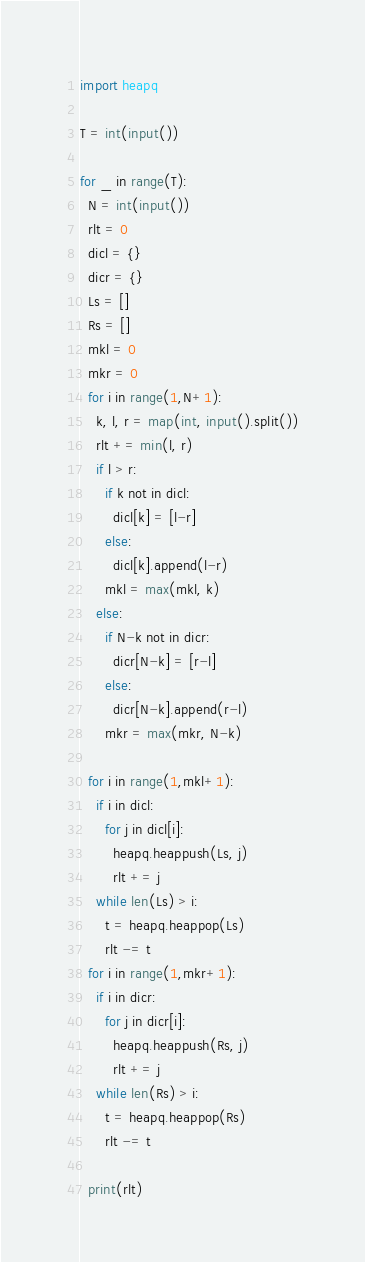Convert code to text. <code><loc_0><loc_0><loc_500><loc_500><_Python_>import heapq

T = int(input())

for _ in range(T):
  N = int(input())
  rlt = 0
  dicl = {}
  dicr = {}
  Ls = []
  Rs = []
  mkl = 0
  mkr = 0
  for i in range(1,N+1):
    k, l, r = map(int, input().split())
    rlt += min(l, r)
    if l > r:
      if k not in dicl:
        dicl[k] = [l-r]
      else:
        dicl[k].append(l-r)
      mkl = max(mkl, k)
    else:
      if N-k not in dicr:
        dicr[N-k] = [r-l]
      else:
        dicr[N-k].append(r-l)
      mkr = max(mkr, N-k)

  for i in range(1,mkl+1):
    if i in dicl:
      for j in dicl[i]:
        heapq.heappush(Ls, j)
        rlt += j
    while len(Ls) > i:
      t = heapq.heappop(Ls)
      rlt -= t
  for i in range(1,mkr+1):
    if i in dicr:
      for j in dicr[i]:
        heapq.heappush(Rs, j)
        rlt += j
    while len(Rs) > i:
      t = heapq.heappop(Rs)
      rlt -= t
      
  print(rlt)</code> 